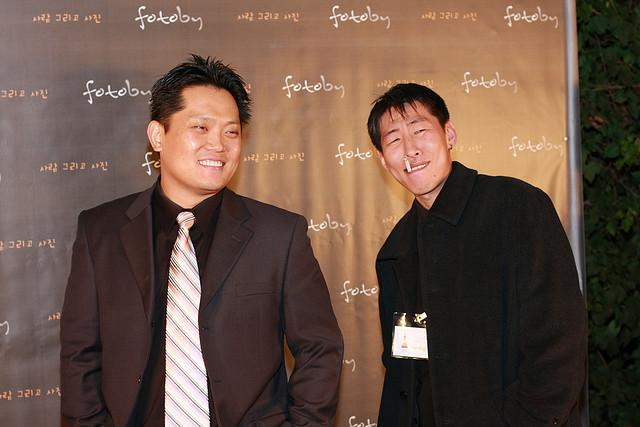Where do these people stand?

Choices:
A) photo backdrop
B) classroom
C) bathroom
D) jail photo backdrop 